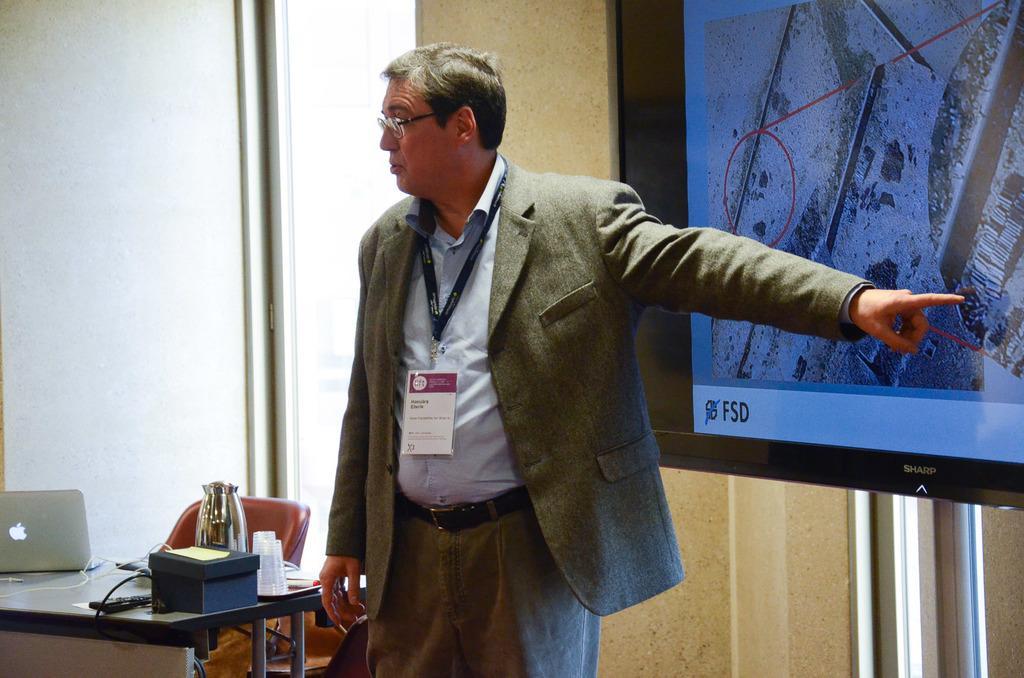How would you summarize this image in a sentence or two? in the picture we can see a person standing there we can also see a table,on the table we can see laptop and a kettle. 